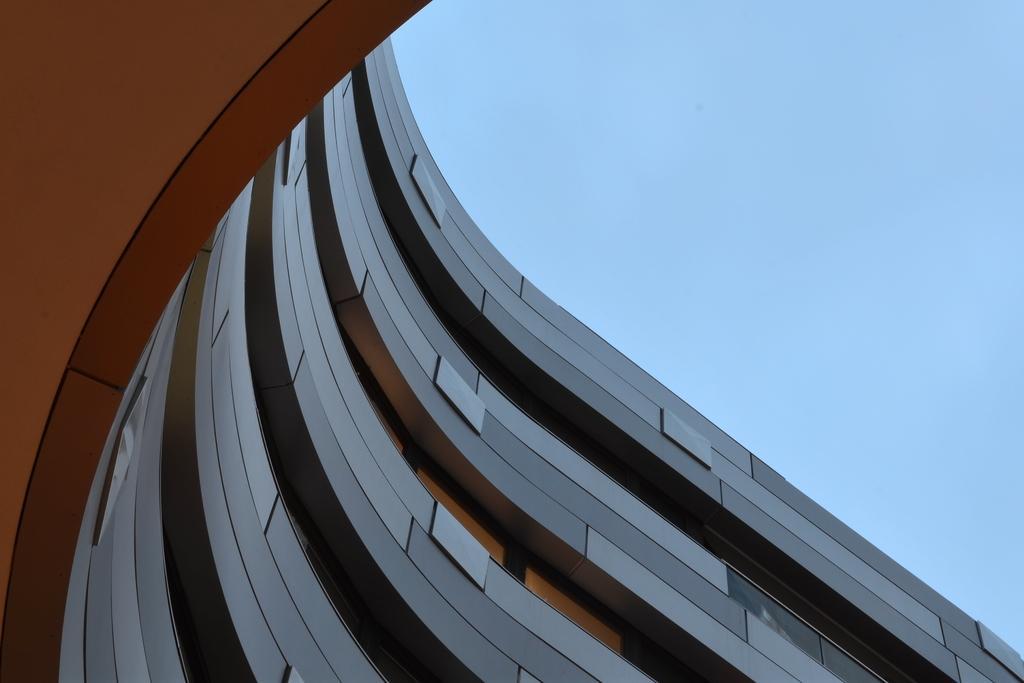Please provide a concise description of this image. In this image, this looks like a four story architectural building. This is the sky. 